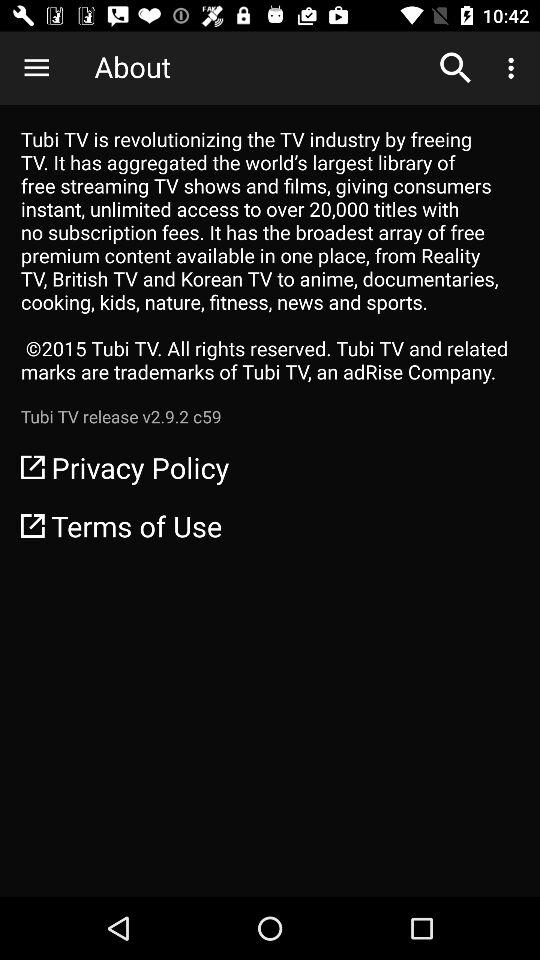What is the version of the application? The version of the application is v2.9.2 c59. 